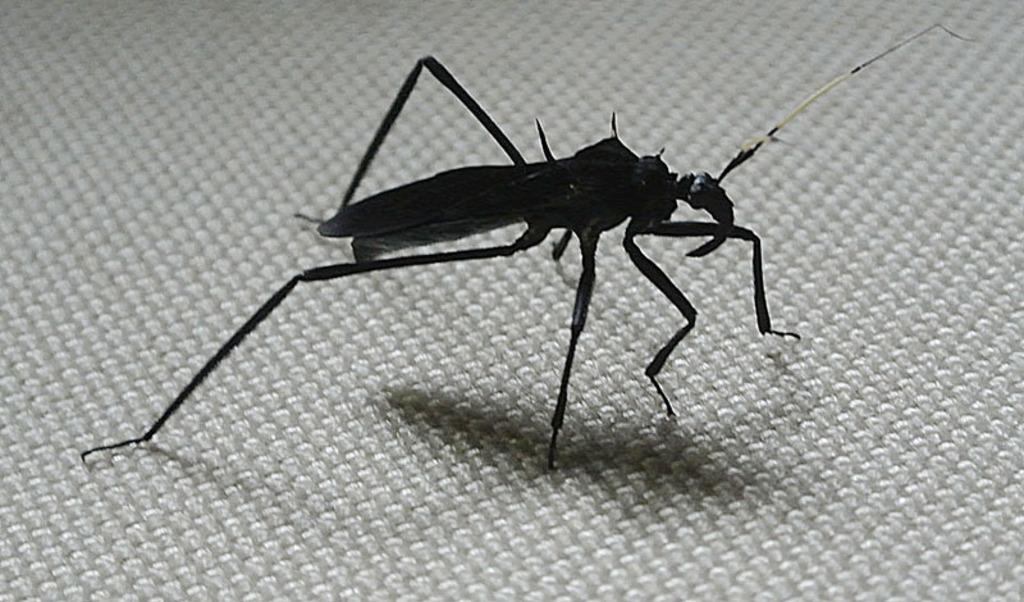What type of insect is present in the image? There is a mosquito in the image. What type of baby is buried in the cemetery in the image? There is no cemetery or baby present in the image; it only features a mosquito. What color is the copper used to make the mosquito in the image? There is no copper used to make the mosquito in the image, as it is a living insect. 